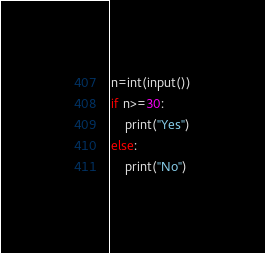Convert code to text. <code><loc_0><loc_0><loc_500><loc_500><_Python_>n=int(input())
if n>=30:
    print("Yes")
else:
    print("No")</code> 